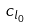Convert formula to latex. <formula><loc_0><loc_0><loc_500><loc_500>c _ { l _ { 0 } }</formula> 